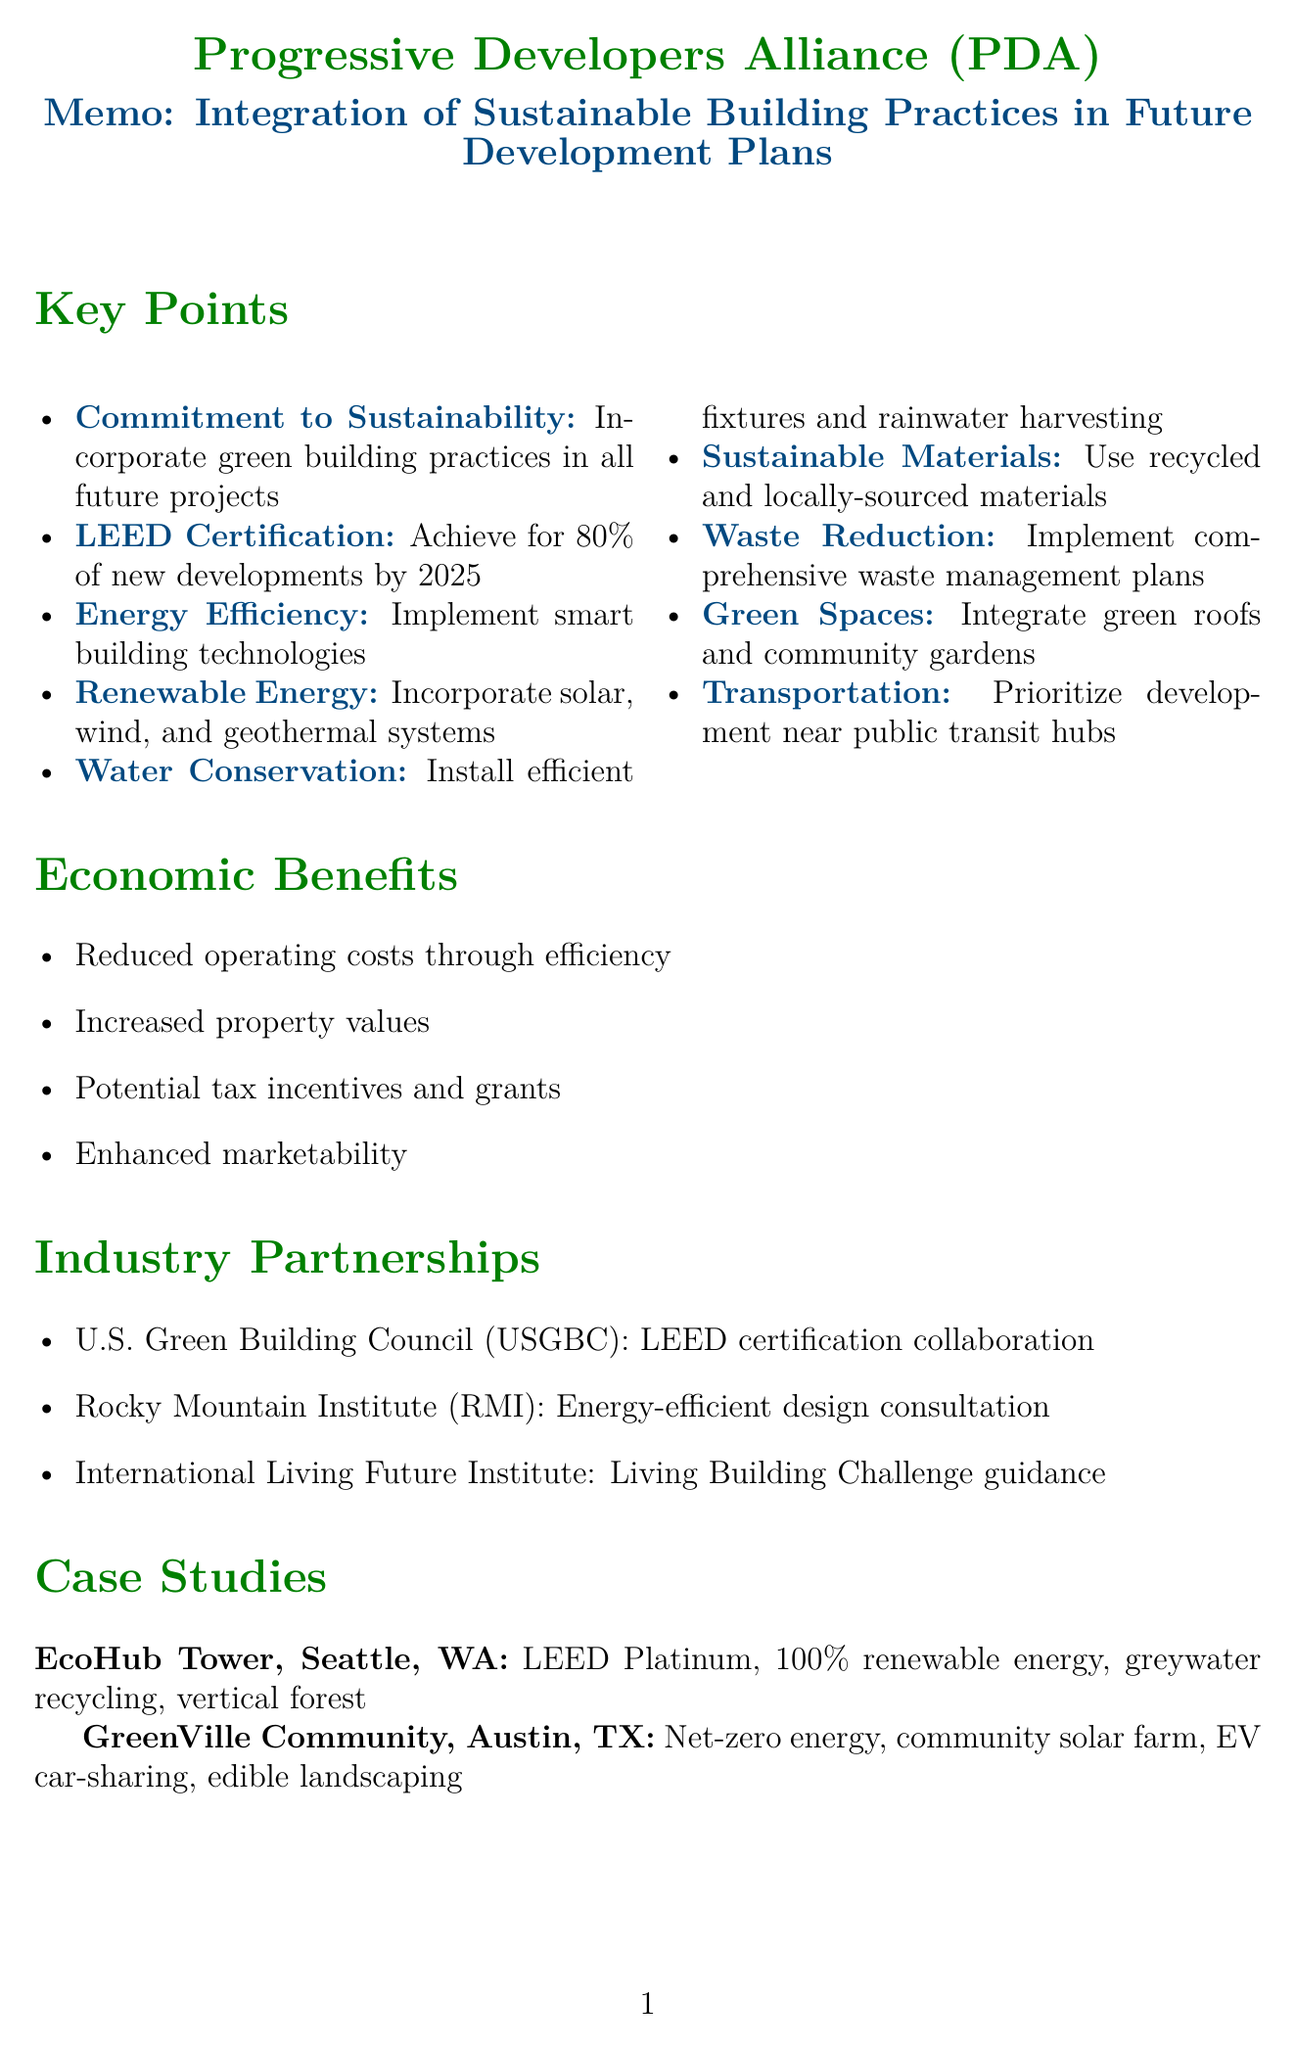What is the organization name? The organization name is provided in the document's header, clearly stated at the beginning.
Answer: Progressive Developers Alliance (PDA) What percentage of new developments aims for LEED certification by 2025? This information is specified in the key points section regarding certification goals.
Answer: 80% What is one of the key features of the EcoHub Tower project? The key features of the EcoHub Tower are listed in the case studies section.
Answer: LEED Platinum certification What is the goal for carbon-neutral operations? The future goals section outlines the target for carbon-neutral operations of the PDA-led developments.
Answer: 2030 Which industry partnership focuses on energy-efficient building design? The document lists industry partnerships along with their purposes; one of them is specifically about energy efficiency.
Answer: Rocky Mountain Institute (RMI) How many economic benefits are listed in total? The economic benefits section presents a clear number of benefits mentioned within.
Answer: Four What type of spaces does the organization prioritize in its development plans? The key points section emphasizes the importance of specific types of developments, highlighting this aspect.
Answer: Green spaces What will the Sustainable Development Fund support? The future goals explain the purpose of establishing the fund in relation to development practices.
Answer: Innovative green building technologies 